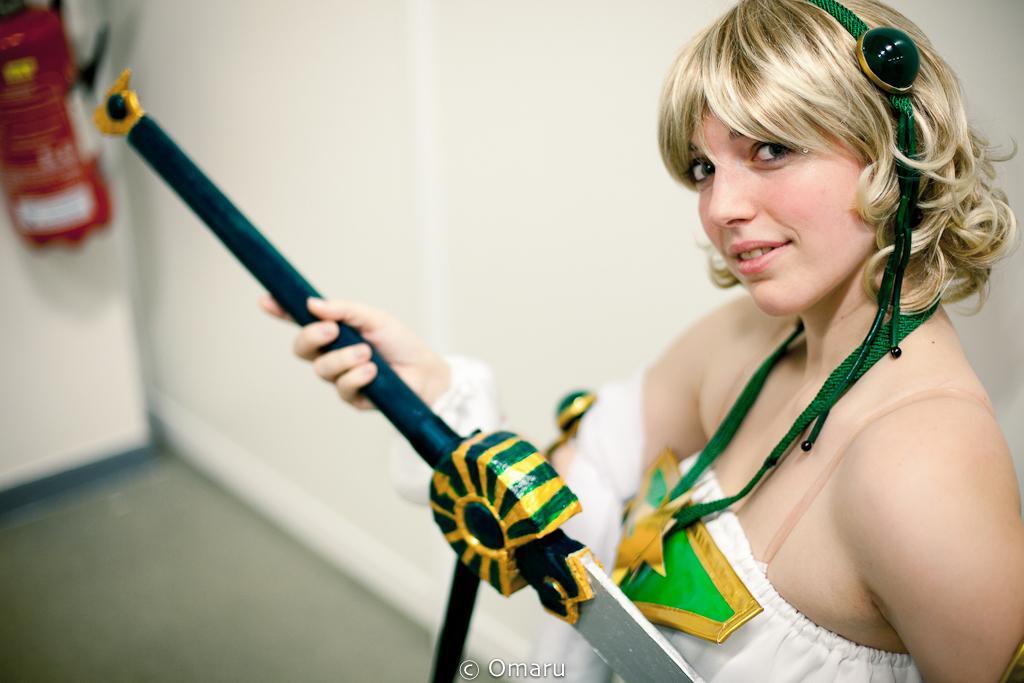How would you summarize this image in a sentence or two? In this image I can see a person wearing white color dress and holding something. Back I can see a white wall and red color object. 